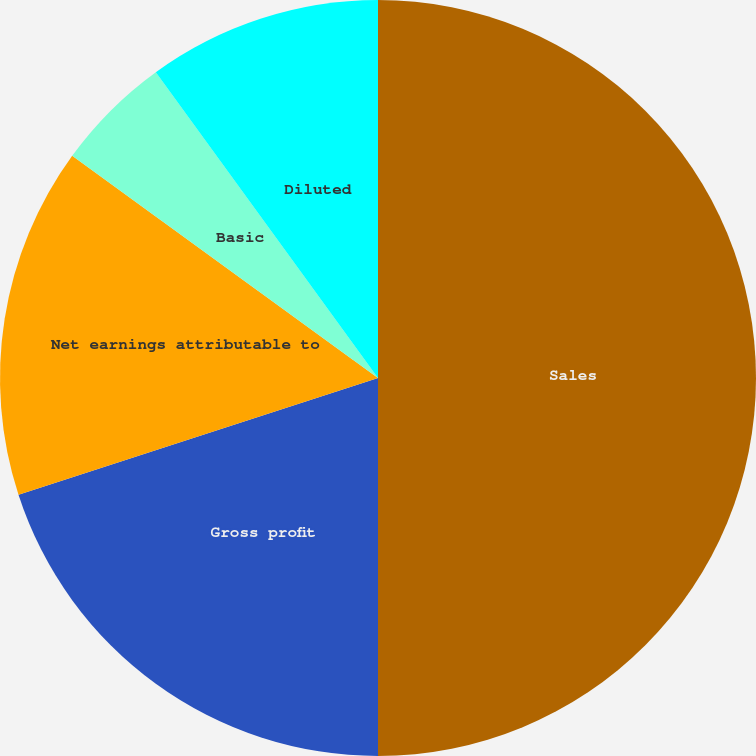Convert chart to OTSL. <chart><loc_0><loc_0><loc_500><loc_500><pie_chart><fcel>Sales<fcel>Gross profit<fcel>Net earnings attributable to<fcel>Basic<fcel>Diluted<fcel>Cash dividends declared per<nl><fcel>50.0%<fcel>20.0%<fcel>15.0%<fcel>5.0%<fcel>10.0%<fcel>0.0%<nl></chart> 